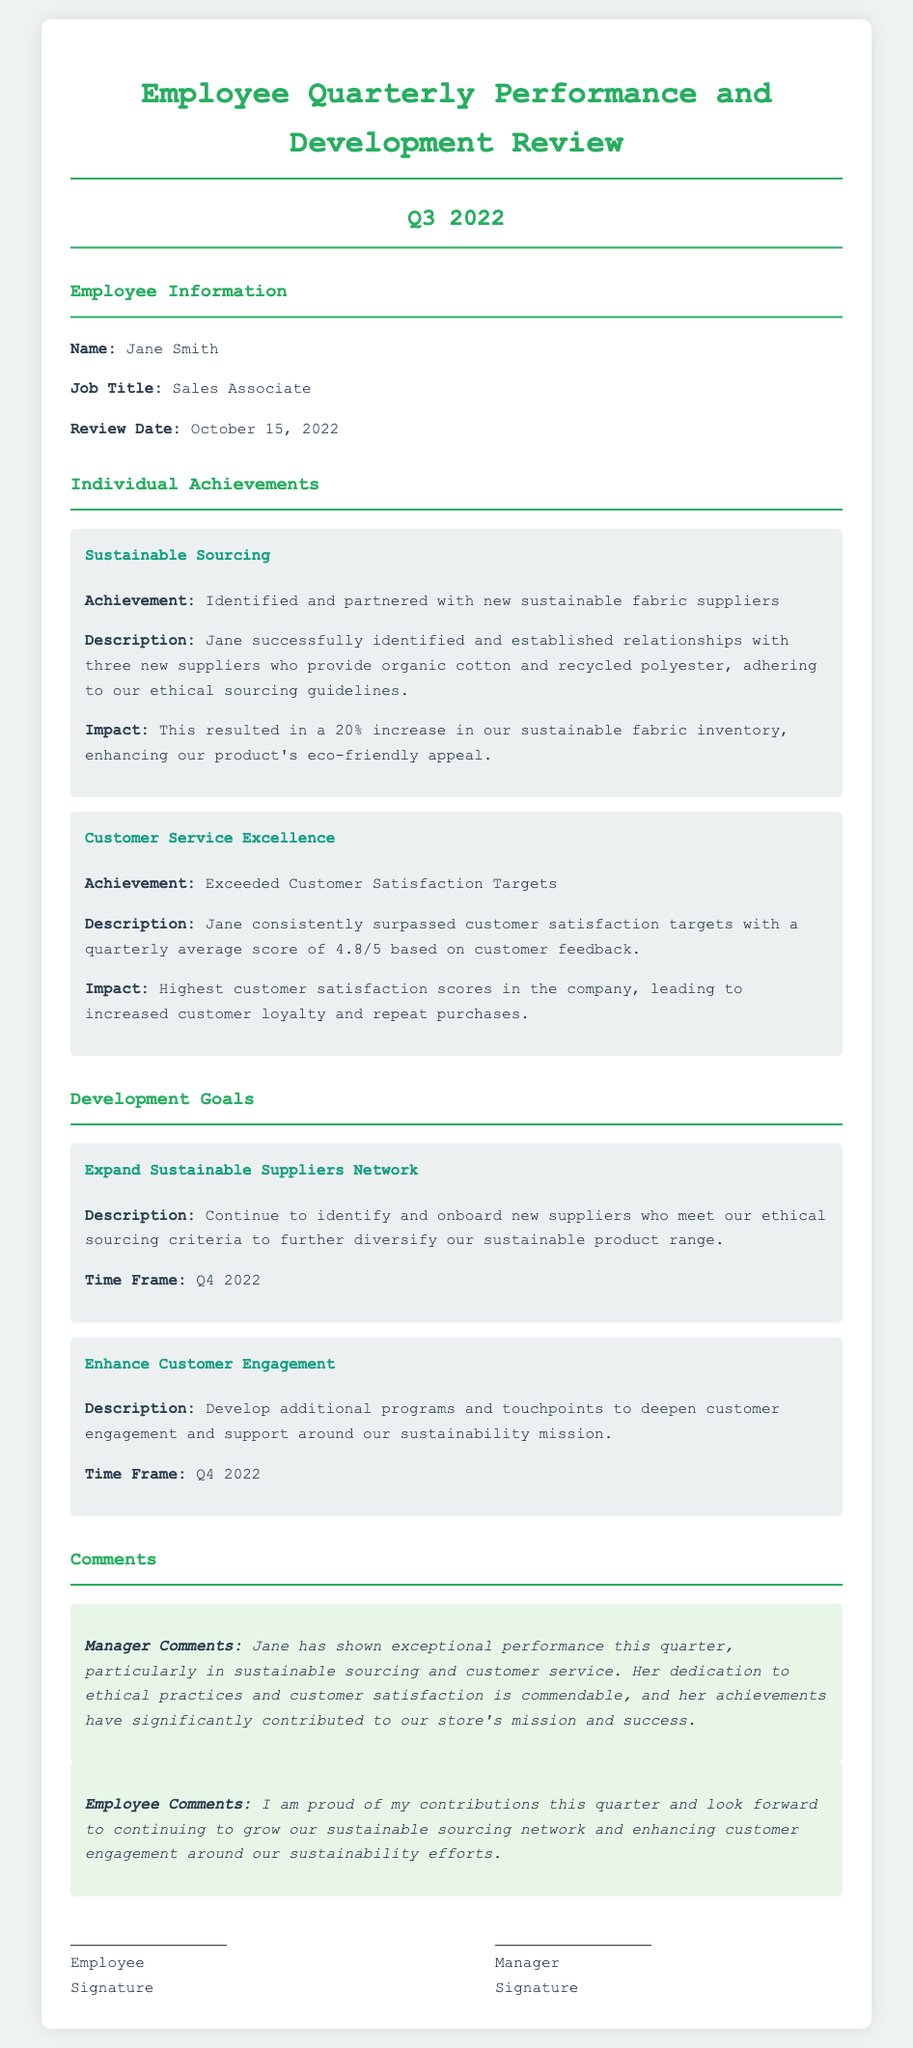what is the employee's name? The employee's name is explicitly mentioned under Employee Information in the document.
Answer: Jane Smith what job title does the employee hold? The job title is listed next to the employee's name under Employee Information.
Answer: Sales Associate what was the quarterly average customer satisfaction score? The score is provided in the Customer Service Excellence achievement section.
Answer: 4.8/5 how many new sustainable suppliers did the employee partner with? The number of new suppliers is given in the Sustainable Sourcing achievement section.
Answer: three what impact did the new suppliers have on sustainable fabric inventory? The impact is noted in the Sustainable Sourcing achievement section regarding inventory increase.
Answer: 20% what is one of the development goals for Q4 2022? The document lists specific goals, and one of them is included in the Development Goals section.
Answer: Expand Sustainable Suppliers Network what do the manager comments highlight about the employee's performance? The manager comments provide a summary of the employee's performance and contributions.
Answer: Exceptional performance what time frame is stated for enhancing customer engagement? The time frame for the goal is mentioned in the corresponding Development Goals section.
Answer: Q4 2022 how does the employee feel about their contributions this quarter? The employee’s thoughts are expressed in the Employee Comments section.
Answer: Proud 